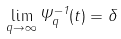Convert formula to latex. <formula><loc_0><loc_0><loc_500><loc_500>\lim _ { q \rightarrow \infty } \Psi ^ { - 1 } _ { q } ( t ) = \delta</formula> 